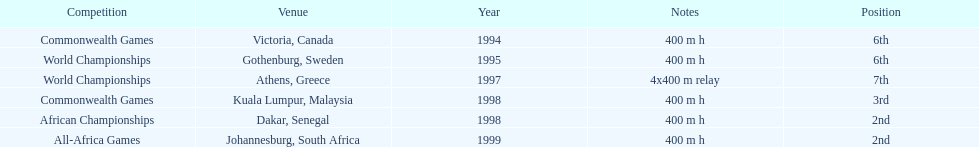I'm looking to parse the entire table for insights. Could you assist me with that? {'header': ['Competition', 'Venue', 'Year', 'Notes', 'Position'], 'rows': [['Commonwealth Games', 'Victoria, Canada', '1994', '400 m h', '6th'], ['World Championships', 'Gothenburg, Sweden', '1995', '400 m h', '6th'], ['World Championships', 'Athens, Greece', '1997', '4x400 m relay', '7th'], ['Commonwealth Games', 'Kuala Lumpur, Malaysia', '1998', '400 m h', '3rd'], ['African Championships', 'Dakar, Senegal', '1998', '400 m h', '2nd'], ['All-Africa Games', 'Johannesburg, South Africa', '1999', '400 m h', '2nd']]} During the 1997 world championships, how lengthy was the relay race that featured ken harden? 4x400 m relay. 